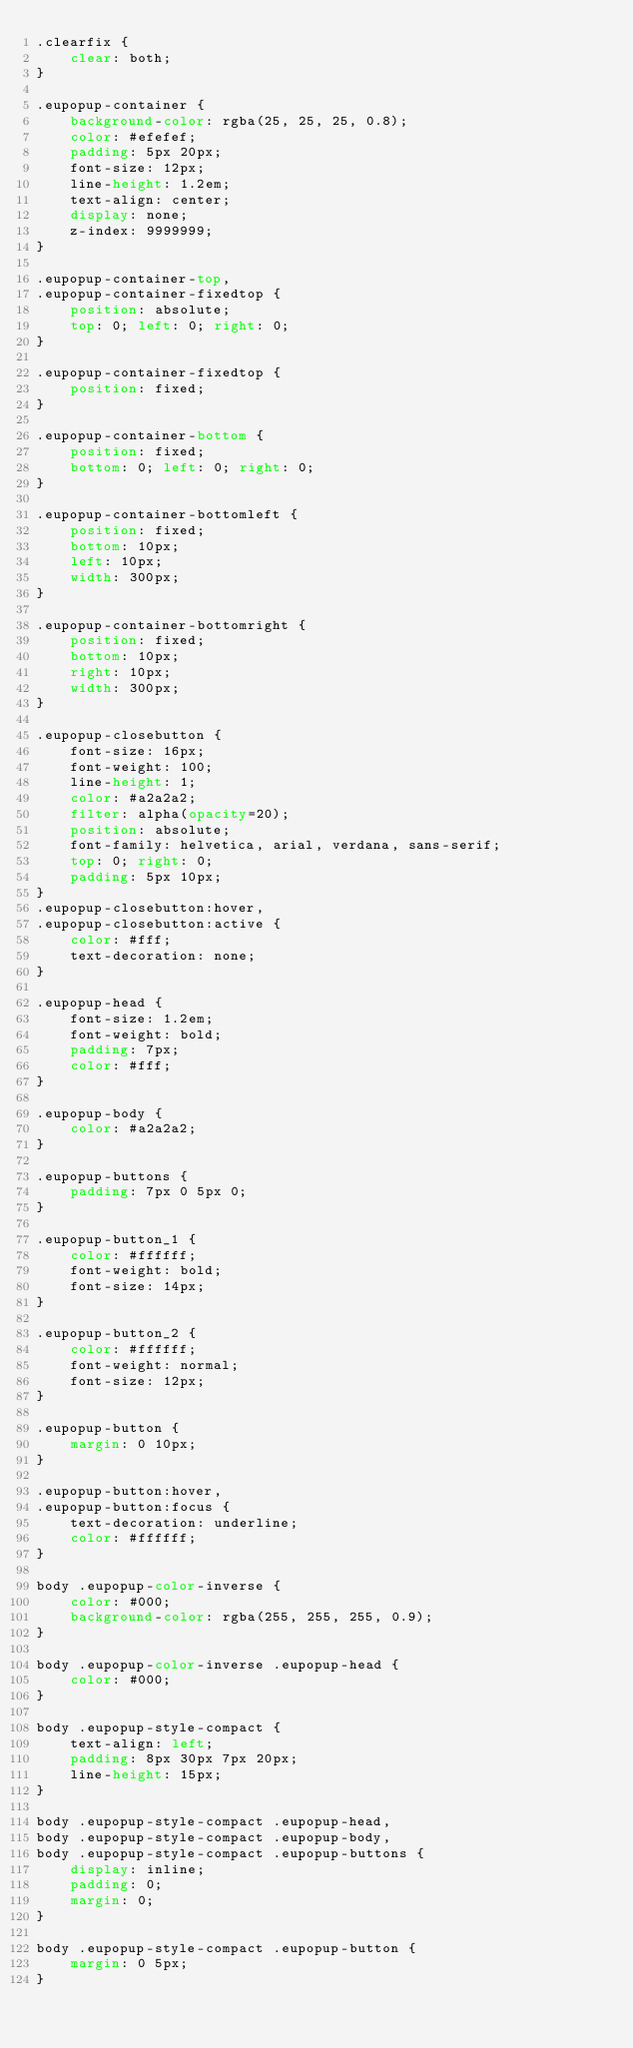Convert code to text. <code><loc_0><loc_0><loc_500><loc_500><_CSS_>.clearfix {
	clear: both;
}

.eupopup-container {
	background-color: rgba(25, 25, 25, 0.8);
	color: #efefef;
	padding: 5px 20px;
	font-size: 12px;
	line-height: 1.2em;
	text-align: center;
	display: none;
	z-index: 9999999;
}

.eupopup-container-top,
.eupopup-container-fixedtop {
	position: absolute;
	top: 0; left: 0; right: 0;
}

.eupopup-container-fixedtop {
	position: fixed;
}

.eupopup-container-bottom {
	position: fixed;
	bottom: 0; left: 0; right: 0;
}

.eupopup-container-bottomleft {
	position: fixed;
	bottom: 10px;
	left: 10px;
	width: 300px;
}

.eupopup-container-bottomright {
	position: fixed;
	bottom: 10px;
	right: 10px;
	width: 300px;
}

.eupopup-closebutton {
	font-size: 16px;
	font-weight: 100;
	line-height: 1;
	color: #a2a2a2;
	filter: alpha(opacity=20);
	position: absolute;
	font-family: helvetica, arial, verdana, sans-serif;
	top: 0; right: 0;
	padding: 5px 10px;
}
.eupopup-closebutton:hover,
.eupopup-closebutton:active {
	color: #fff;
	text-decoration: none;
}

.eupopup-head {
	font-size: 1.2em;
	font-weight: bold;
	padding: 7px;
	color: #fff;
}

.eupopup-body {
	color: #a2a2a2;
}

.eupopup-buttons {
	padding: 7px 0 5px 0;
}

.eupopup-button_1 {
	color: #ffffff;
	font-weight: bold;
	font-size: 14px;
}

.eupopup-button_2 {
	color: #ffffff;
	font-weight: normal;
	font-size: 12px;
}

.eupopup-button {
	margin: 0 10px;
}

.eupopup-button:hover,
.eupopup-button:focus {
	text-decoration: underline;
	color: #ffffff;
}

body .eupopup-color-inverse {
	color: #000;
	background-color: rgba(255, 255, 255, 0.9);
}

body .eupopup-color-inverse .eupopup-head {
	color: #000;
}

body .eupopup-style-compact {
	text-align: left;
	padding: 8px 30px 7px 20px;
	line-height: 15px;
}

body .eupopup-style-compact .eupopup-head,
body .eupopup-style-compact .eupopup-body,
body .eupopup-style-compact .eupopup-buttons {
	display: inline;
	padding: 0;
	margin: 0;
}

body .eupopup-style-compact .eupopup-button {
	margin: 0 5px;
}
</code> 